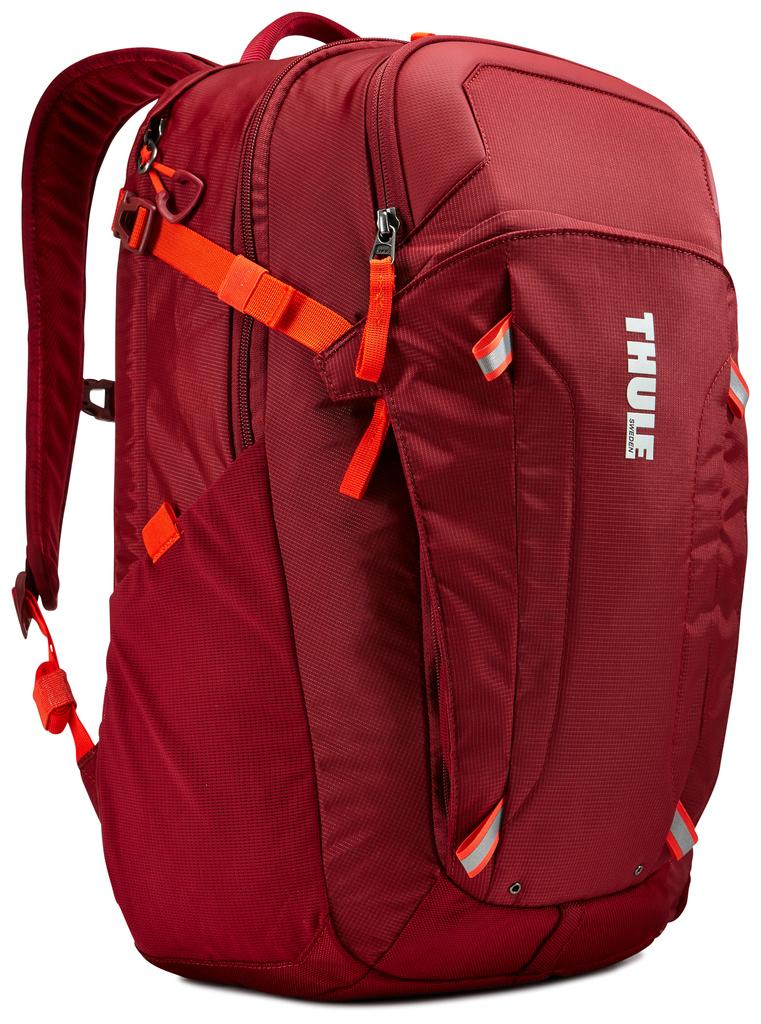<image>
Share a concise interpretation of the image provided. A large red Thule backpack was made in Sweden. 